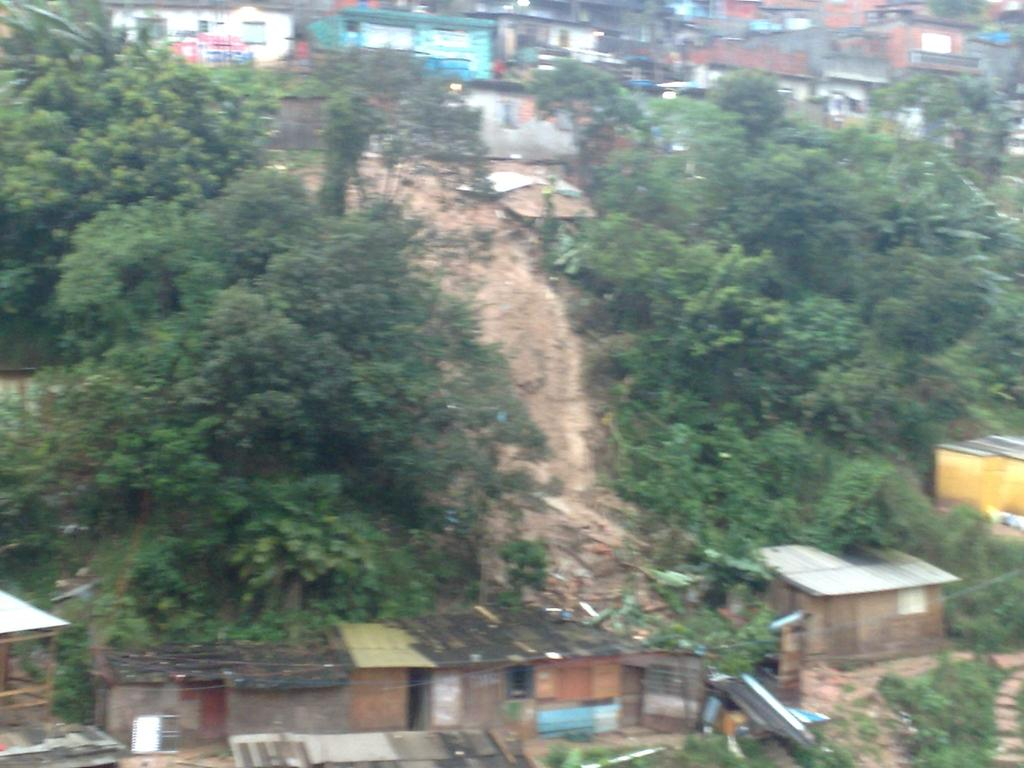What type of natural elements can be seen in the image? There are trees in the image. What type of geographical feature is present in the image? There is a mountain in the image. Are there any man-made structures visible in the image? Yes, there is a building in the image. What type of passenger is visible in the image? There are no passengers present in the image; it features trees, a mountain, and a building. Is there a fight happening in the image? There is no fight depicted in the image; it shows a peaceful scene with trees, a mountain, and a building. 